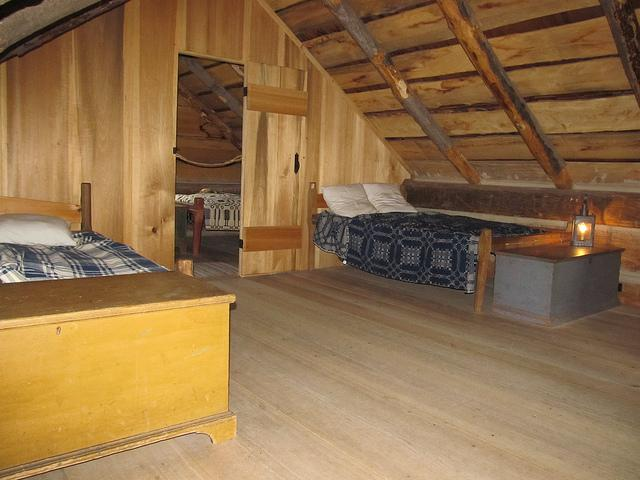What color of light is emanated by the lantern on the top of the footlocker? Please explain your reasoning. orange. An orange grow emanates from the rectangular metal structure with glass doors on the right side of the image. 